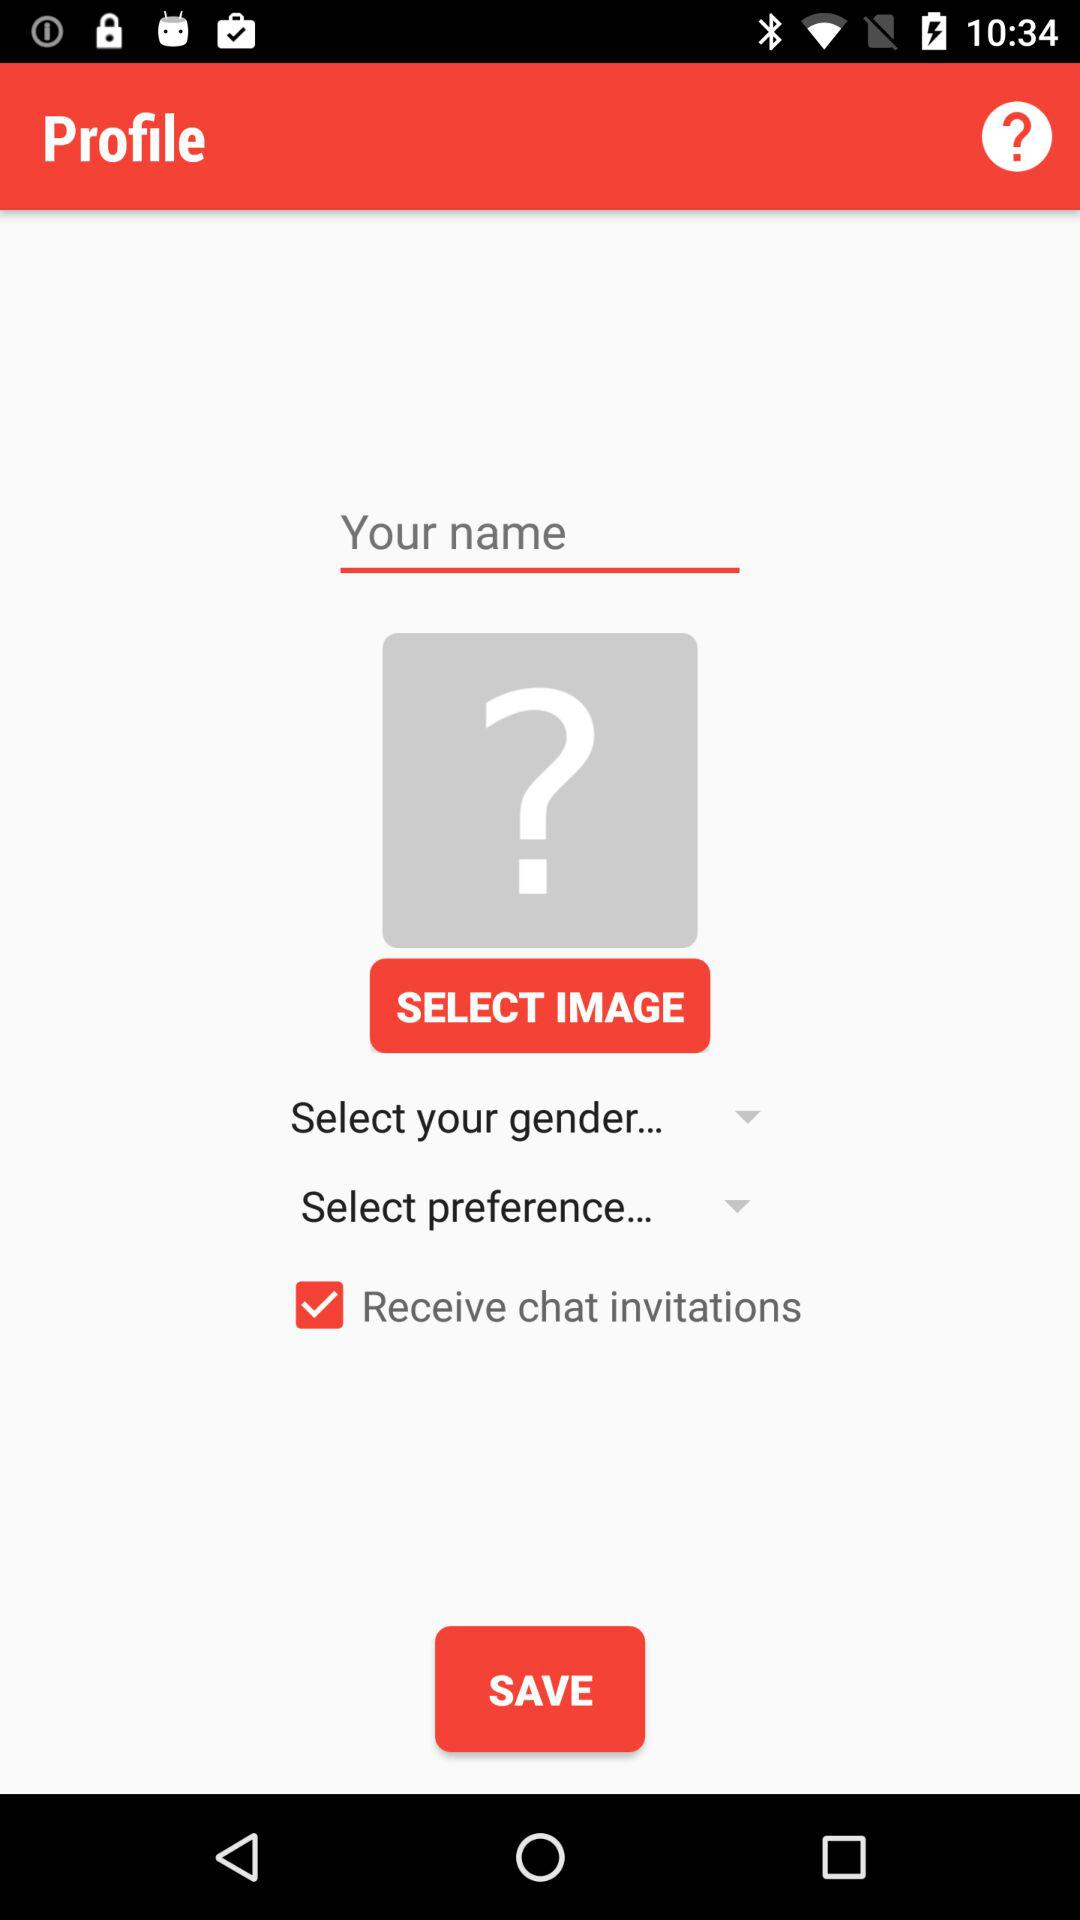What is the status of "Receive chat invitations"? The status is "on". 